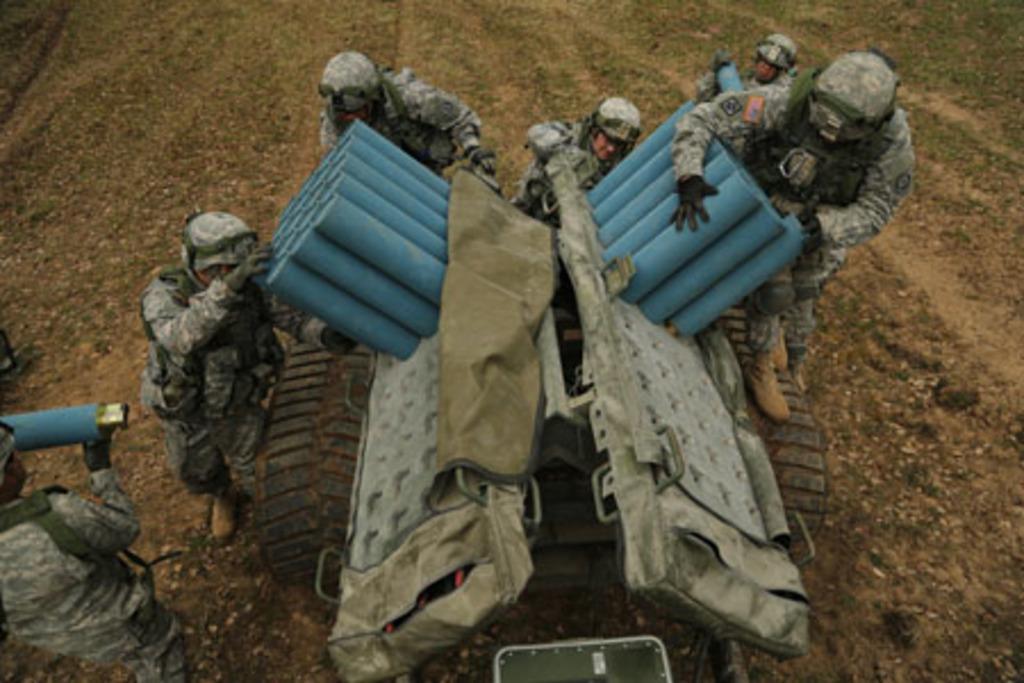In one or two sentences, can you explain what this image depicts? In this image there are group of people standing and holding the launchers, which are on the vehicle. 